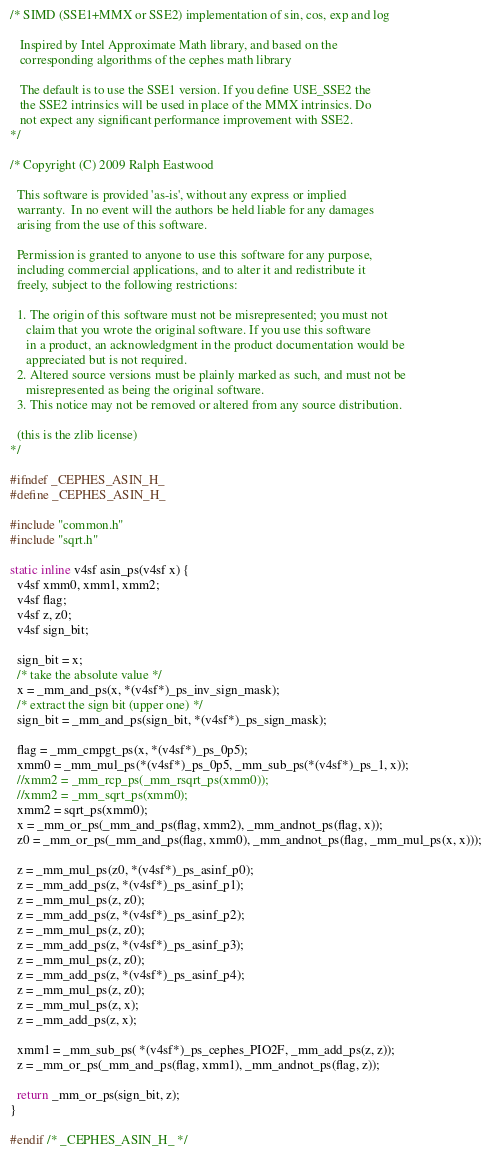Convert code to text. <code><loc_0><loc_0><loc_500><loc_500><_C_>/* SIMD (SSE1+MMX or SSE2) implementation of sin, cos, exp and log

   Inspired by Intel Approximate Math library, and based on the
   corresponding algorithms of the cephes math library

   The default is to use the SSE1 version. If you define USE_SSE2 the
   the SSE2 intrinsics will be used in place of the MMX intrinsics. Do
   not expect any significant performance improvement with SSE2.
*/

/* Copyright (C) 2009 Ralph Eastwood

  This software is provided 'as-is', without any express or implied
  warranty.  In no event will the authors be held liable for any damages
  arising from the use of this software.

  Permission is granted to anyone to use this software for any purpose,
  including commercial applications, and to alter it and redistribute it
  freely, subject to the following restrictions:

  1. The origin of this software must not be misrepresented; you must not
     claim that you wrote the original software. If you use this software
     in a product, an acknowledgment in the product documentation would be
     appreciated but is not required.
  2. Altered source versions must be plainly marked as such, and must not be
     misrepresented as being the original software.
  3. This notice may not be removed or altered from any source distribution.

  (this is the zlib license)
*/

#ifndef _CEPHES_ASIN_H_
#define _CEPHES_ASIN_H_

#include "common.h"
#include "sqrt.h"

static inline v4sf asin_ps(v4sf x) {
  v4sf xmm0, xmm1, xmm2;
  v4sf flag;
  v4sf z, z0;
  v4sf sign_bit;
  
  sign_bit = x;
  /* take the absolute value */
  x = _mm_and_ps(x, *(v4sf*)_ps_inv_sign_mask);
  /* extract the sign bit (upper one) */
  sign_bit = _mm_and_ps(sign_bit, *(v4sf*)_ps_sign_mask);
  
  flag = _mm_cmpgt_ps(x, *(v4sf*)_ps_0p5);
  xmm0 = _mm_mul_ps(*(v4sf*)_ps_0p5, _mm_sub_ps(*(v4sf*)_ps_1, x));
  //xmm2 = _mm_rcp_ps(_mm_rsqrt_ps(xmm0));
  //xmm2 = _mm_sqrt_ps(xmm0);
  xmm2 = sqrt_ps(xmm0);
  x = _mm_or_ps(_mm_and_ps(flag, xmm2), _mm_andnot_ps(flag, x));
  z0 = _mm_or_ps(_mm_and_ps(flag, xmm0), _mm_andnot_ps(flag, _mm_mul_ps(x, x)));
  
  z = _mm_mul_ps(z0, *(v4sf*)_ps_asinf_p0);
  z = _mm_add_ps(z, *(v4sf*)_ps_asinf_p1);
  z = _mm_mul_ps(z, z0);
  z = _mm_add_ps(z, *(v4sf*)_ps_asinf_p2);
  z = _mm_mul_ps(z, z0);
  z = _mm_add_ps(z, *(v4sf*)_ps_asinf_p3);
  z = _mm_mul_ps(z, z0);
  z = _mm_add_ps(z, *(v4sf*)_ps_asinf_p4);
  z = _mm_mul_ps(z, z0);
  z = _mm_mul_ps(z, x);
  z = _mm_add_ps(z, x);
  
  xmm1 = _mm_sub_ps( *(v4sf*)_ps_cephes_PIO2F, _mm_add_ps(z, z));
  z = _mm_or_ps(_mm_and_ps(flag, xmm1), _mm_andnot_ps(flag, z));
  
  return _mm_or_ps(sign_bit, z);
}

#endif /* _CEPHES_ASIN_H_ */
</code> 